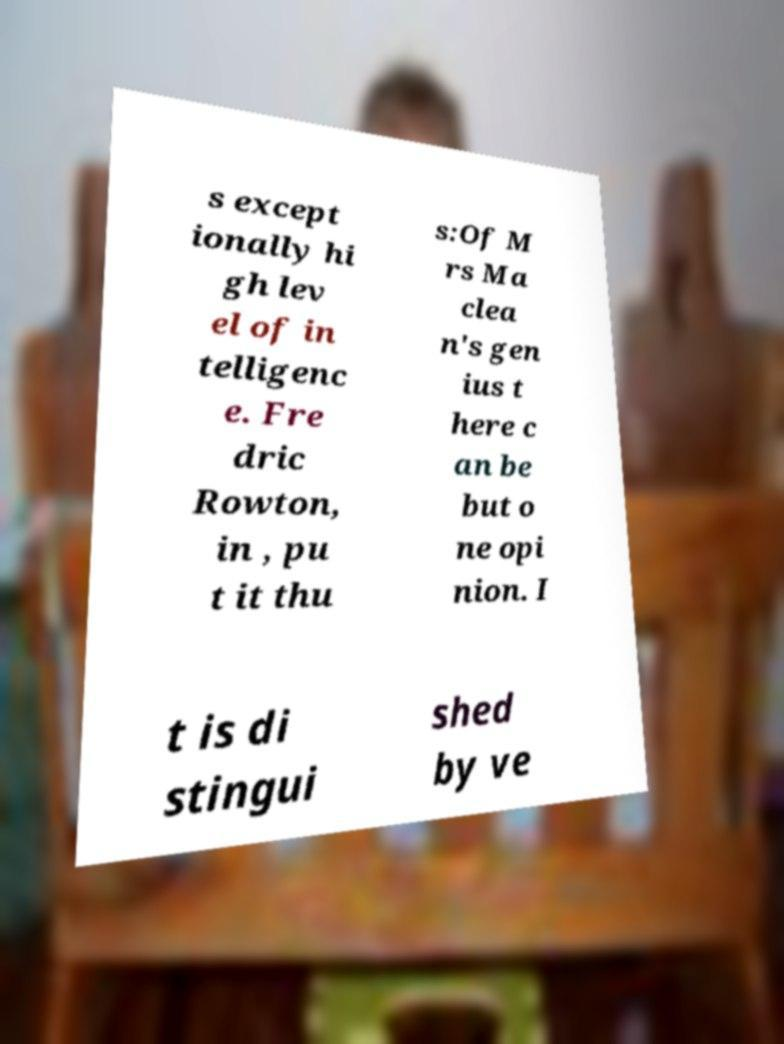Please read and relay the text visible in this image. What does it say? s except ionally hi gh lev el of in telligenc e. Fre dric Rowton, in , pu t it thu s:Of M rs Ma clea n's gen ius t here c an be but o ne opi nion. I t is di stingui shed by ve 